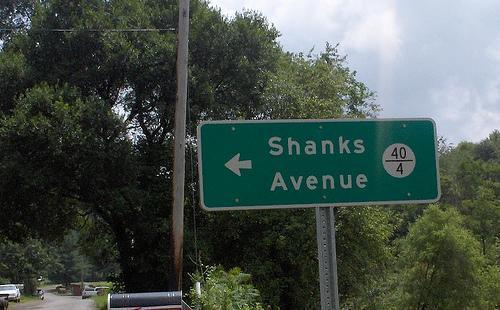How many street signs are there?
Give a very brief answer. 1. How many street names have white in them?
Give a very brief answer. 1. 